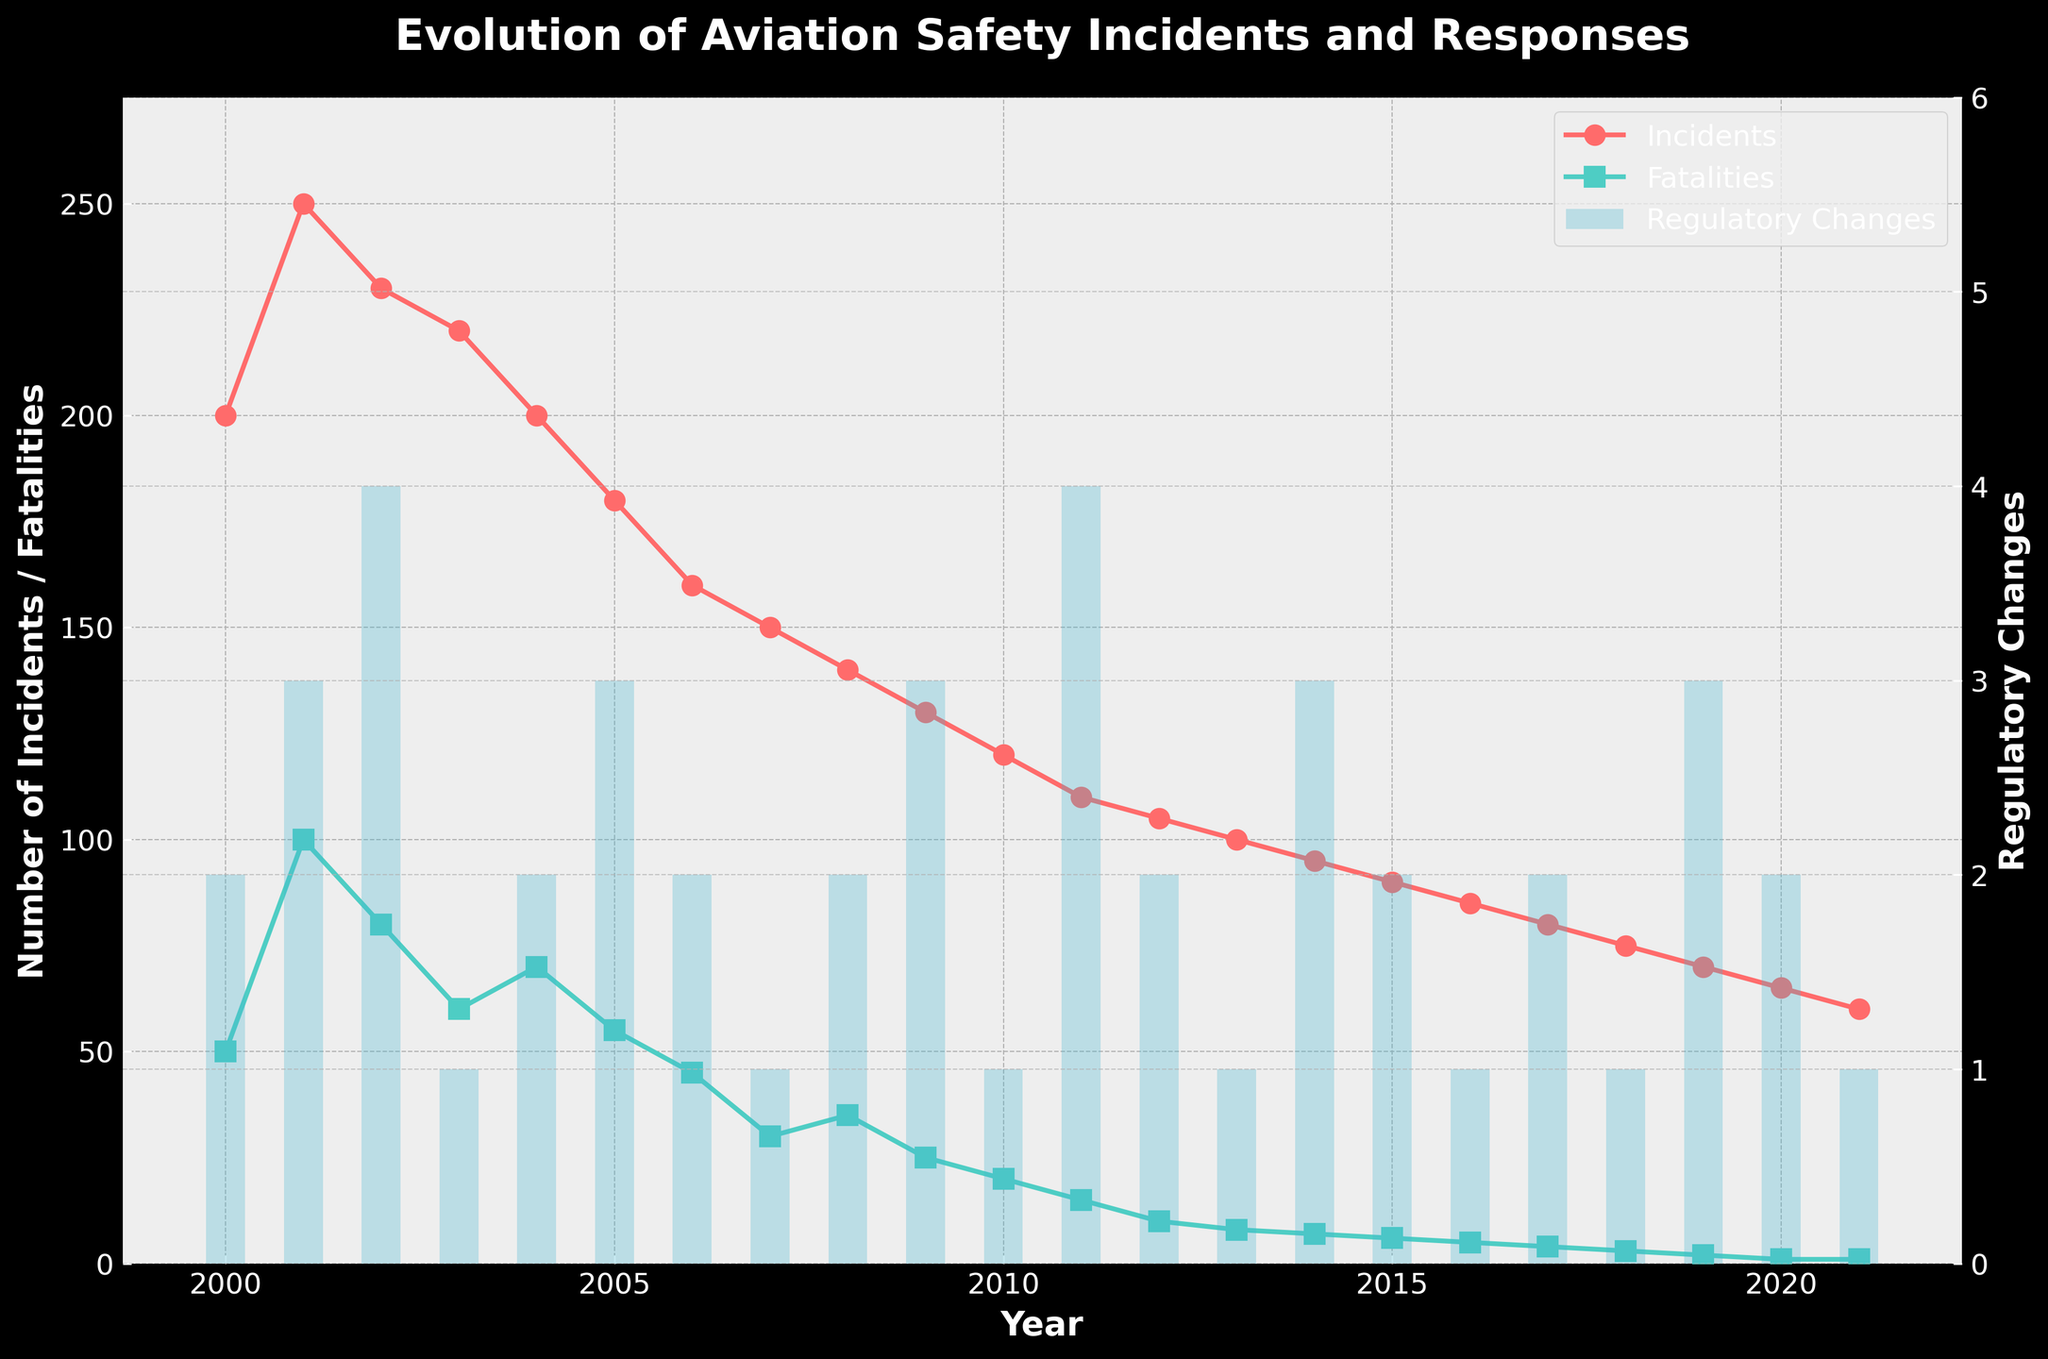What trend do you observe in the number of incidents over the years? The number of incidents shows a decreasing trend from 2000 to 2021. Initially, there were 200 incidents in 2000, and by 2021, the number reduced to 60.
Answer: Decreasing What was the year with the highest number of fatalities? By looking at the plot, the highest point for fatalities occurs in the year 2001, with 100 fatalities.
Answer: 2001 Which year had the highest number of regulatory changes? The highest bar for regulatory changes is in the year 2011, where there were 4 regulatory changes.
Answer: 2011 What is the difference in the number of incidents between the years 2000 and 2021? In 2000, there were 200 incidents. By 2021, this number decreased to 60. So, 200 - 60 is 140.
Answer: 140 In which year were the regulatory changes equal to 3? The years where the bar for regulatory changes reaches a height of 3 are 2001, 2005, 2009, 2014, and 2019.
Answer: 2001, 2005, 2009, 2014, 2019 How did the number of fatalities change from 2001 to 2002? In 2001, there were 100 fatalities, and in 2002, there were 80 fatalities. The difference is 100 - 80, which is a decrease of 20.
Answer: Decreased by 20 Considering the trend from 2000 to 2021, what is the average number of incidents per year? Sum the number of incidents from 2000 to 2021, then divide by the number of years (22). (200+250+230+220+200+180+160+150+140+130+120+110+105+100+95+90+85+80+75+70+65+60)/22 is approximately 131.6.
Answer: 131.6 Which year saw the biggest drop in the number of incidents compared to the previous year? The biggest drop can be found by comparing yearly decreases across the plot. The steepest decline seems to be from 2001 (250) to 2002 (230), and the drop is 20 incidents.
Answer: 2001 to 2002 Did fatalities always decrease when the number of regulatory changes increased? This requires comparing each year. For example, in 2001, regulatory changes increased but fatalities increased; in 2005, regulatory changes increased, but fatalities slightly decreased; it wasn't always consistent.
Answer: No What is the relationship between the number of incidents and regulatory changes? Generally, the number of incidents decreases over the years as regulatory changes are made, indicating a potential positive impact of regulations on safety. This correlation can be visually observed on the plot.
Answer: Negative correlation 